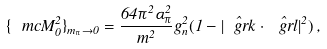<formula> <loc_0><loc_0><loc_500><loc_500>\{ \ m c { M } _ { 0 } ^ { 2 } \} _ { m _ { \pi } \to 0 } = \frac { 6 4 \pi ^ { 2 } \alpha _ { \pi } ^ { 2 } } { m ^ { 2 } } g _ { n } ^ { 2 } ( 1 - \hat { | \ g r { k } } \cdot \hat { \ g r { l } } | ^ { 2 } ) \, ,</formula> 